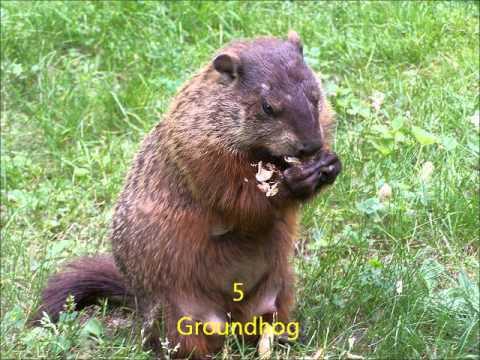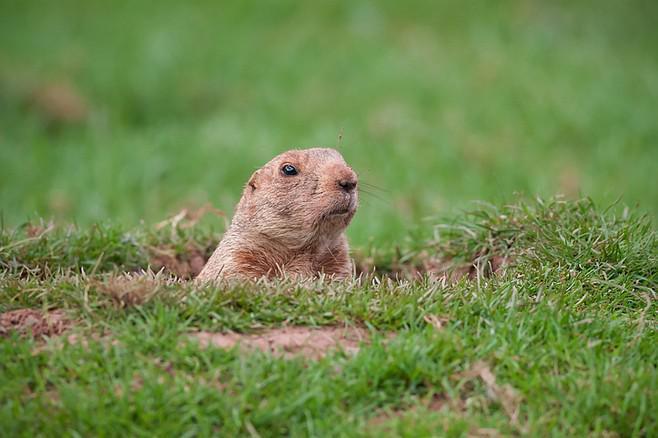The first image is the image on the left, the second image is the image on the right. For the images displayed, is the sentence "There are only two animals and at least one appears to be eating something." factually correct? Answer yes or no. Yes. The first image is the image on the left, the second image is the image on the right. Examine the images to the left and right. Is the description "At least one animal is eating." accurate? Answer yes or no. Yes. 